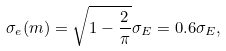<formula> <loc_0><loc_0><loc_500><loc_500>\sigma _ { e } ( m ) = \sqrt { 1 - \frac { 2 } { \pi } } \sigma _ { E } = 0 . 6 \sigma _ { E } ,</formula> 